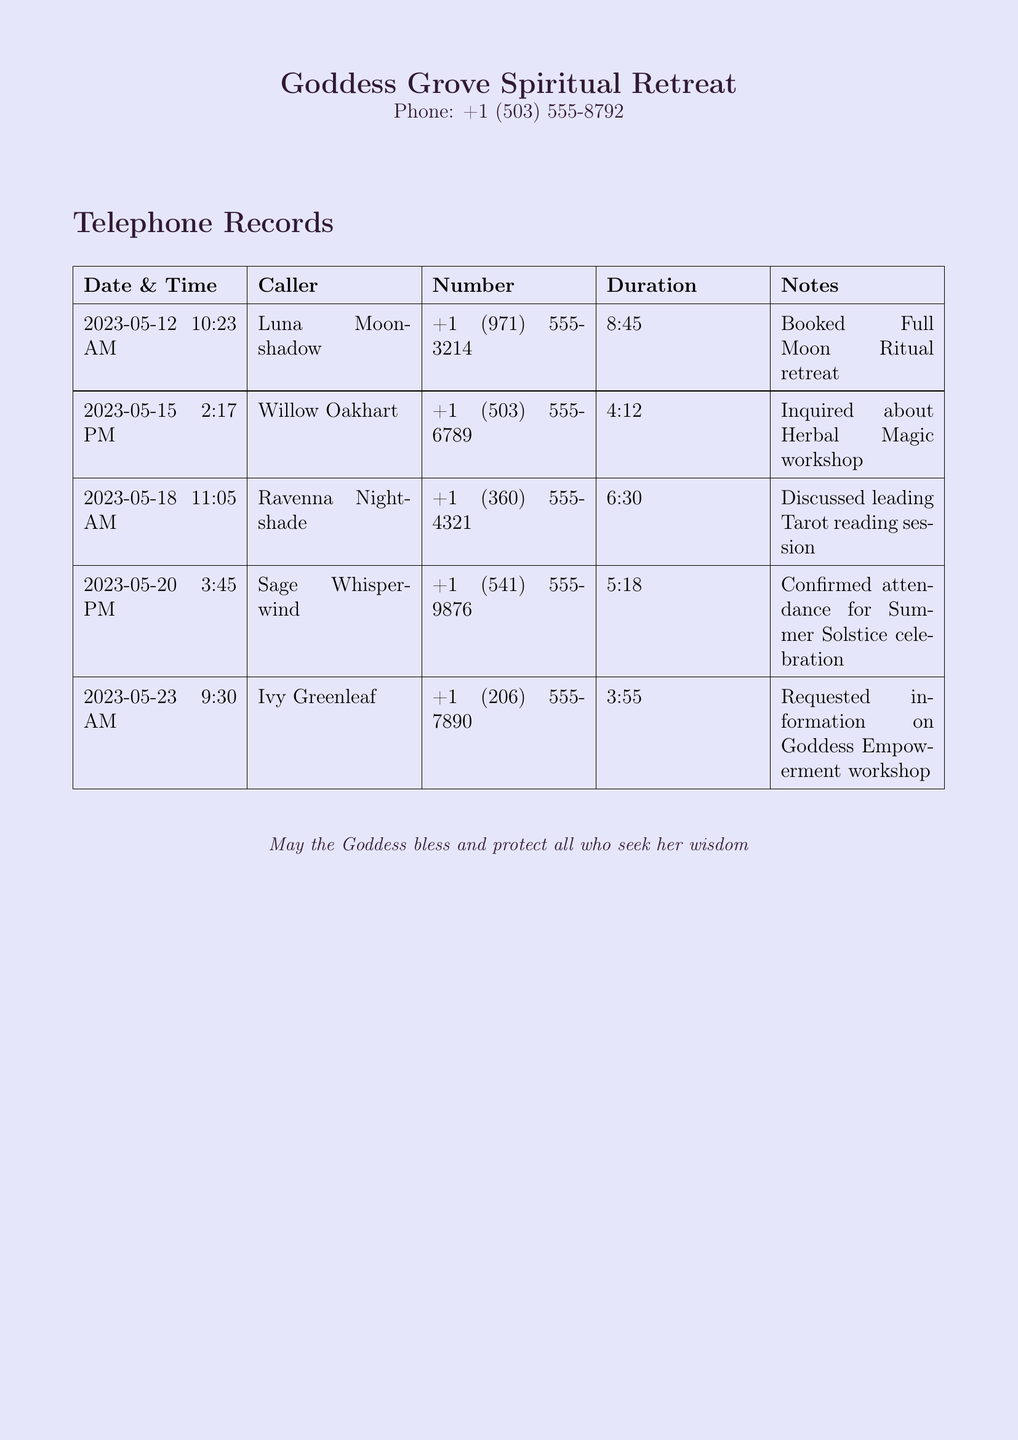what is the phone number of the retreat center? The phone number is provided at the top of the document.
Answer: +1 (503) 555-8792 who called on May 20th? This information is found in the records table under the corresponding date.
Answer: Sage Whisperwind what was the duration of the call from Ravenna Nightshade? The duration is noted in the table under the caller's name.
Answer: 6:30 how many calls were made regarding workshops? This requires counting the relevant entries in the records.
Answer: 3 which caller inquired about the Herbal Magic workshop? The caller's name is detailed in the records table for their inquiry.
Answer: Willow Oakhart what time did Luna Moonshadow call? The time of the call is specified in the table.
Answer: 10:23 AM what is the main purpose of calls recorded? The notes section describes the reasons for each call.
Answer: Inquiries and bookings what date did Ivy Greenleaf call? The date is clearly stated in the records table.
Answer: 2023-05-23 